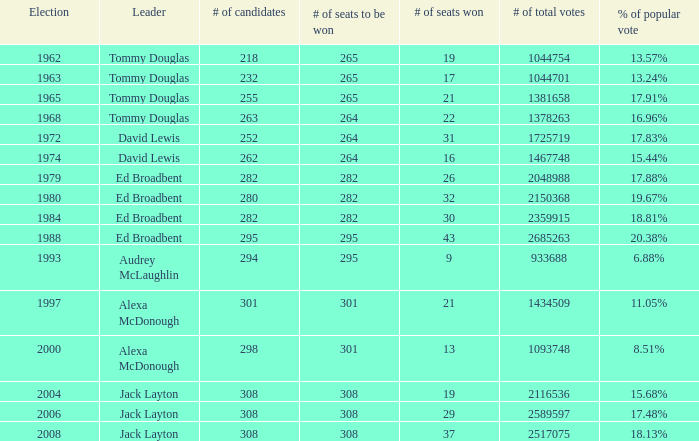Name the number of candidates for # of seats won being 43 295.0. 